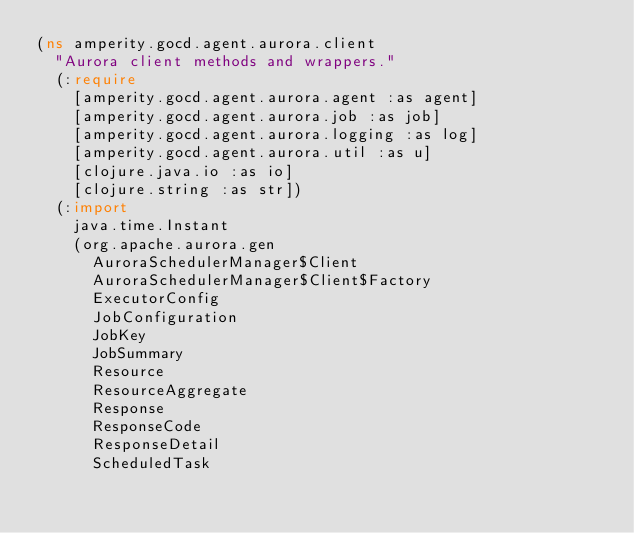<code> <loc_0><loc_0><loc_500><loc_500><_Clojure_>(ns amperity.gocd.agent.aurora.client
  "Aurora client methods and wrappers."
  (:require
    [amperity.gocd.agent.aurora.agent :as agent]
    [amperity.gocd.agent.aurora.job :as job]
    [amperity.gocd.agent.aurora.logging :as log]
    [amperity.gocd.agent.aurora.util :as u]
    [clojure.java.io :as io]
    [clojure.string :as str])
  (:import
    java.time.Instant
    (org.apache.aurora.gen
      AuroraSchedulerManager$Client
      AuroraSchedulerManager$Client$Factory
      ExecutorConfig
      JobConfiguration
      JobKey
      JobSummary
      Resource
      ResourceAggregate
      Response
      ResponseCode
      ResponseDetail
      ScheduledTask</code> 